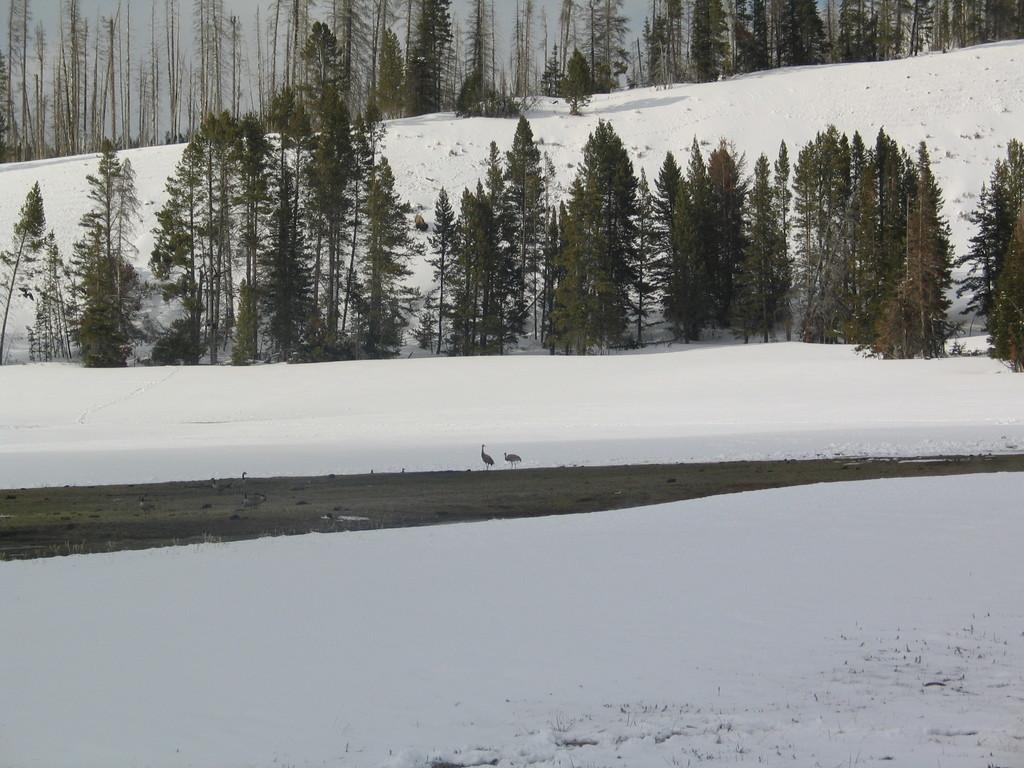What type of landscape is shown in the image? The image depicts a snowland. What animals can be seen on the surface of the water? There are birds on the surface of the water. What type of vegetation is present in the image? Trees are present in the image. What part of the natural environment is visible behind the trees? The sky is visible behind the trees. What type of grain is being harvested in the image? There is no grain present in the image; it depicts a snowland with birds and trees. Can you see a guitar being played in the image? There is no guitar present in the image. 